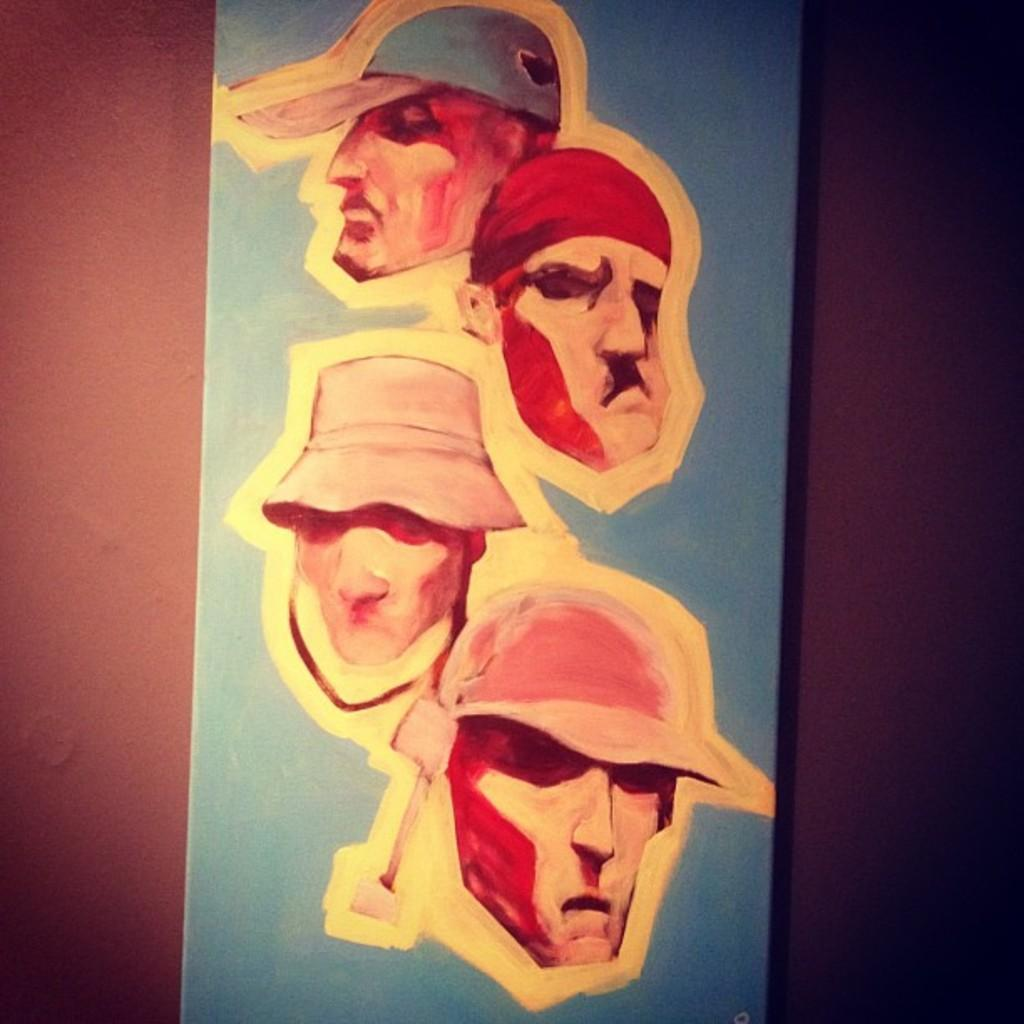What is the main object in the center of the image? There is a board in the center of the image. What is depicted on the board? The board has a painting of people on it. What can be seen in the background of the image? There is a wall visible in the background of the image. What type of ornament is hanging from the ceiling in the image? There is no ornament hanging from the ceiling in the image; it only features a board with a painting and a wall in the background. 